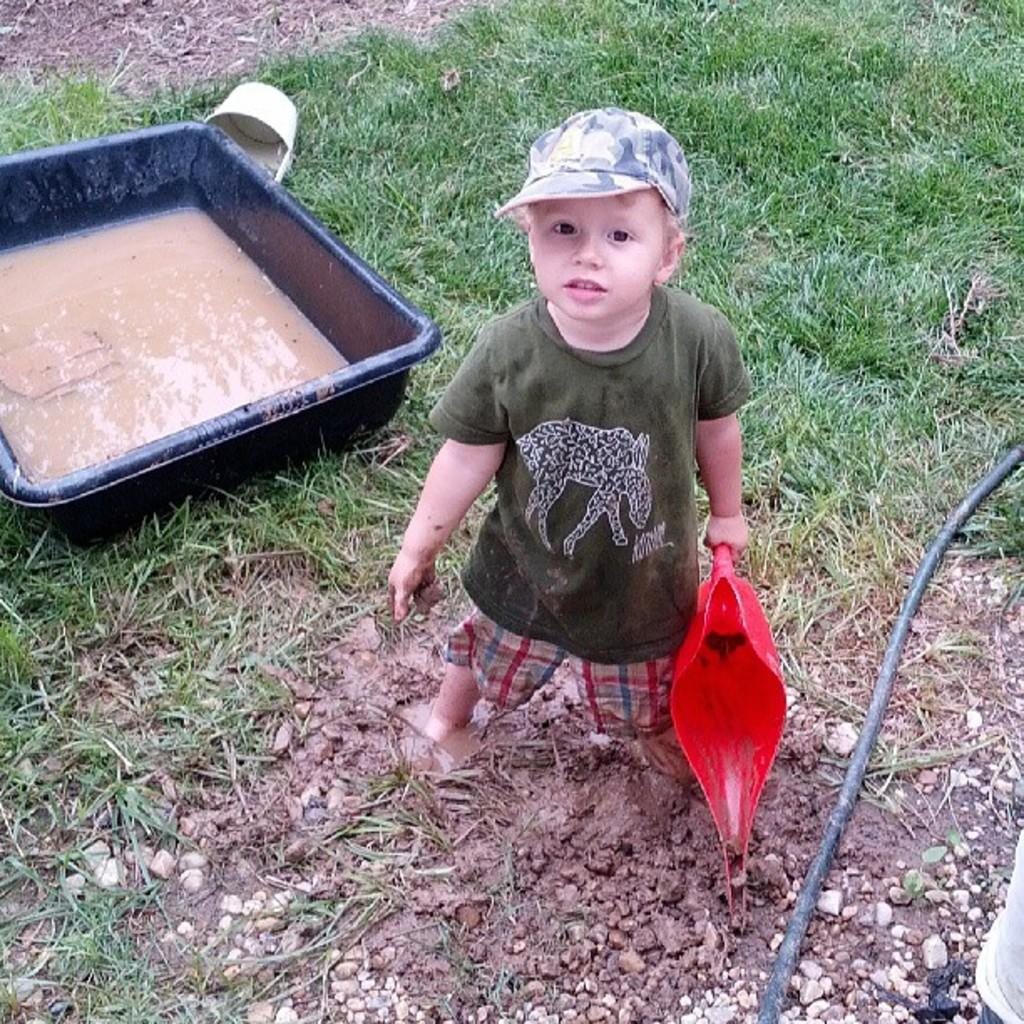What is the child in the image doing? The child is standing in the image and holding a mug. What can be seen in the child's hand? The child is holding a mug. What type of structure is visible in the image? There is a pipe visible in the image. What type of terrain is present in the image? Grass is present in the image. What is the liquid in the tub in the image? There is mud water in a tub in the image. Can you confirm the presence of a mug in the image? Yes, there is a mug in the image. How many pigs are visible in the image? There are no pigs present in the image. What type of appliance is being used by the child in the image? There is no appliance being used by the child in the image. 